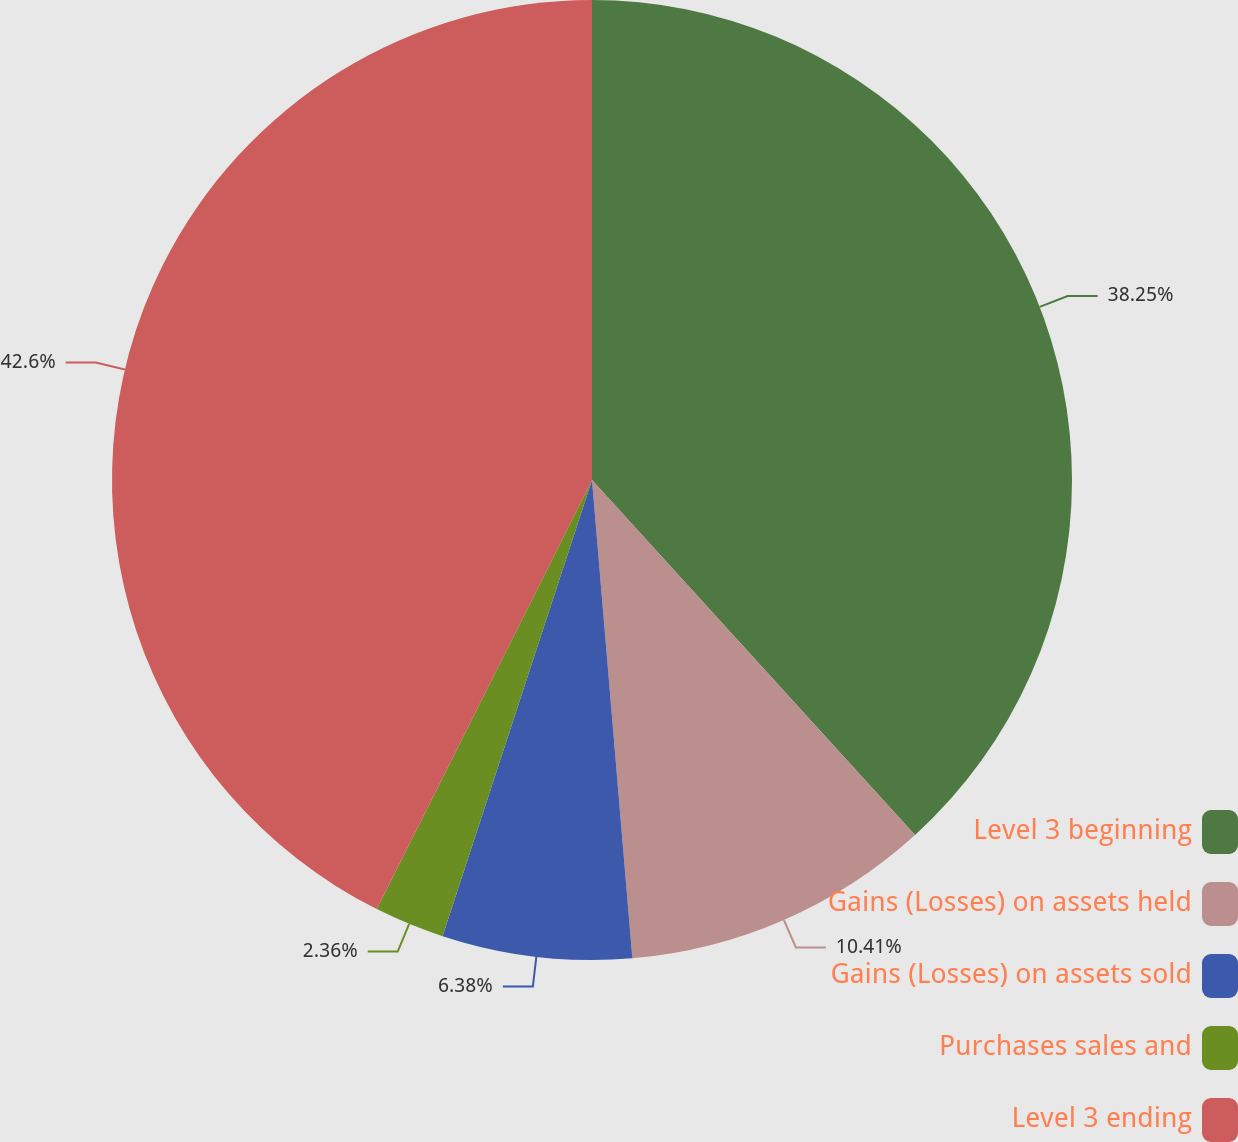Convert chart to OTSL. <chart><loc_0><loc_0><loc_500><loc_500><pie_chart><fcel>Level 3 beginning<fcel>Gains (Losses) on assets held<fcel>Gains (Losses) on assets sold<fcel>Purchases sales and<fcel>Level 3 ending<nl><fcel>38.25%<fcel>10.41%<fcel>6.38%<fcel>2.36%<fcel>42.6%<nl></chart> 